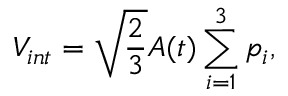Convert formula to latex. <formula><loc_0><loc_0><loc_500><loc_500>V _ { i n t } = \sqrt { \frac { 2 } { 3 } } A ( t ) \sum _ { i = 1 } ^ { 3 } p _ { i } ,</formula> 